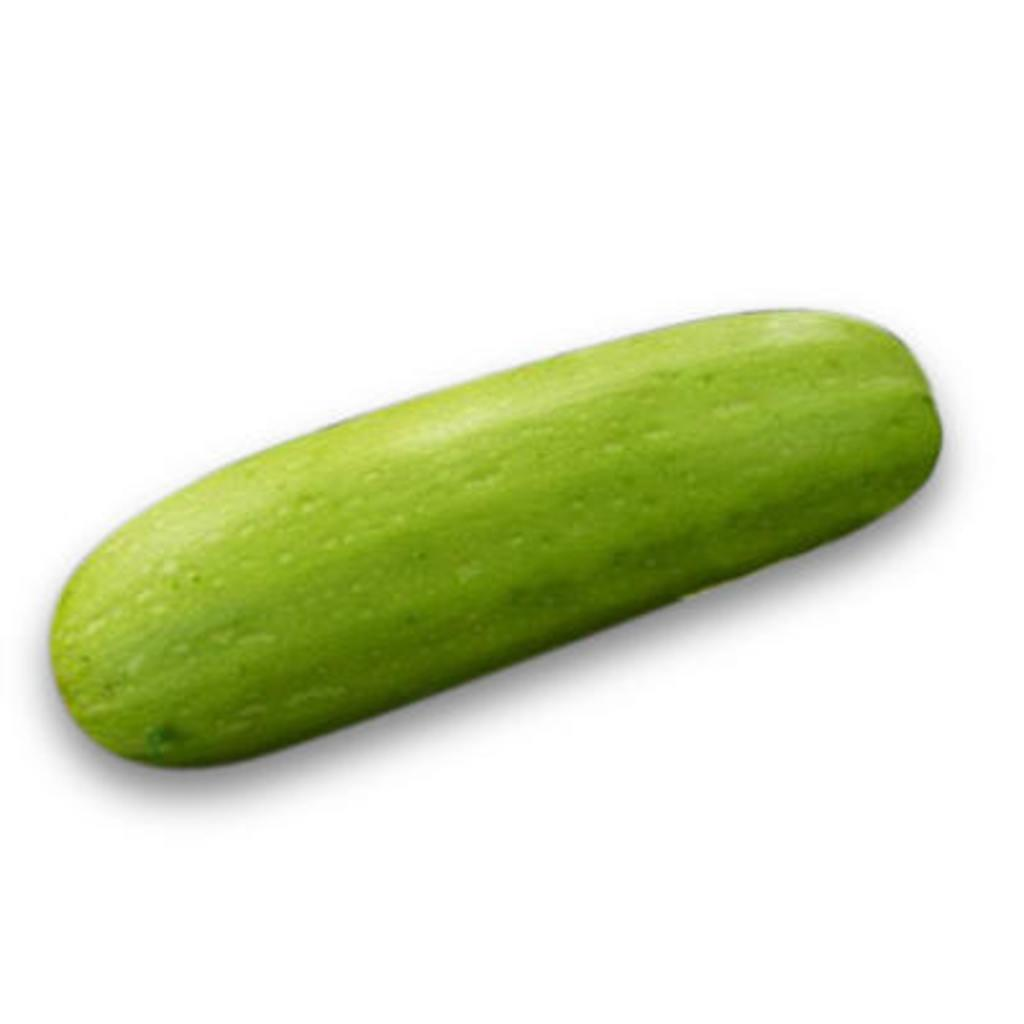What is the main subject of the image? The main subject of the image is a cucumber. What color is the cucumber? The cucumber is green in color. Where is the cucumber placed in the image? The cucumber is on a white surface. What is the color of the background in the image? The background of the image is white. What type of pies are being taught in the image? There are no pies or teaching activities present in the image; it features a cucumber on a white surface with a white background. What is the quiver used for in the image? There is no quiver present in the image; it features a cucumber on a white surface with a white background. 